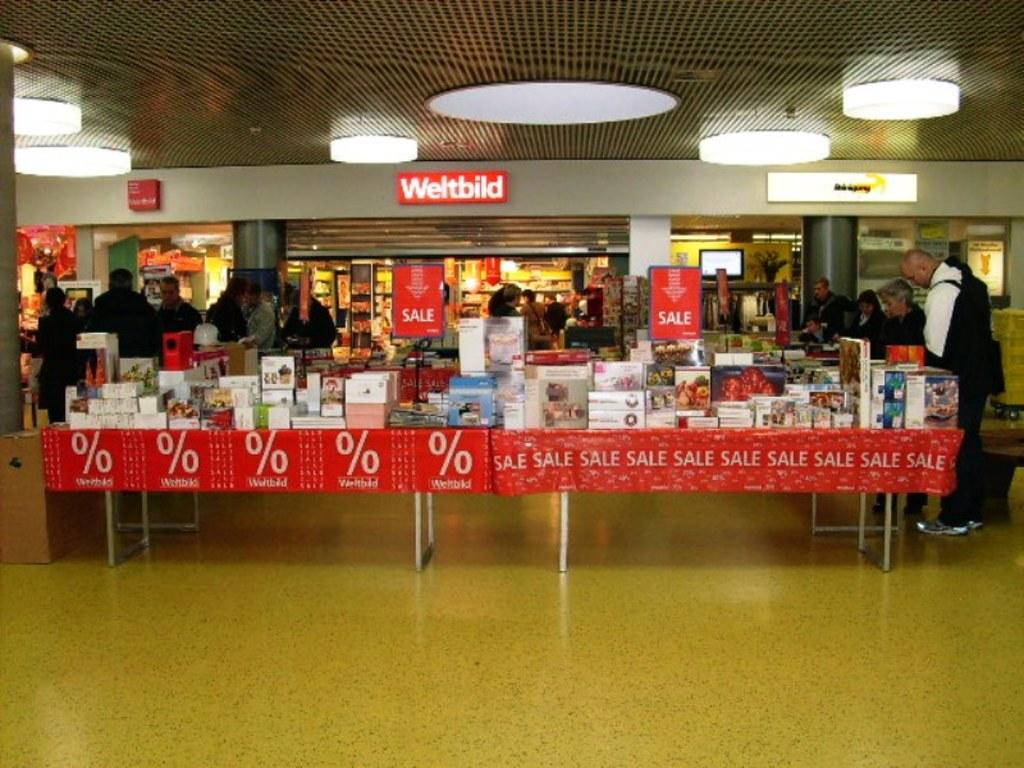<image>
Give a short and clear explanation of the subsequent image. Booths covered in items are set up in front o the Weltbild store. 